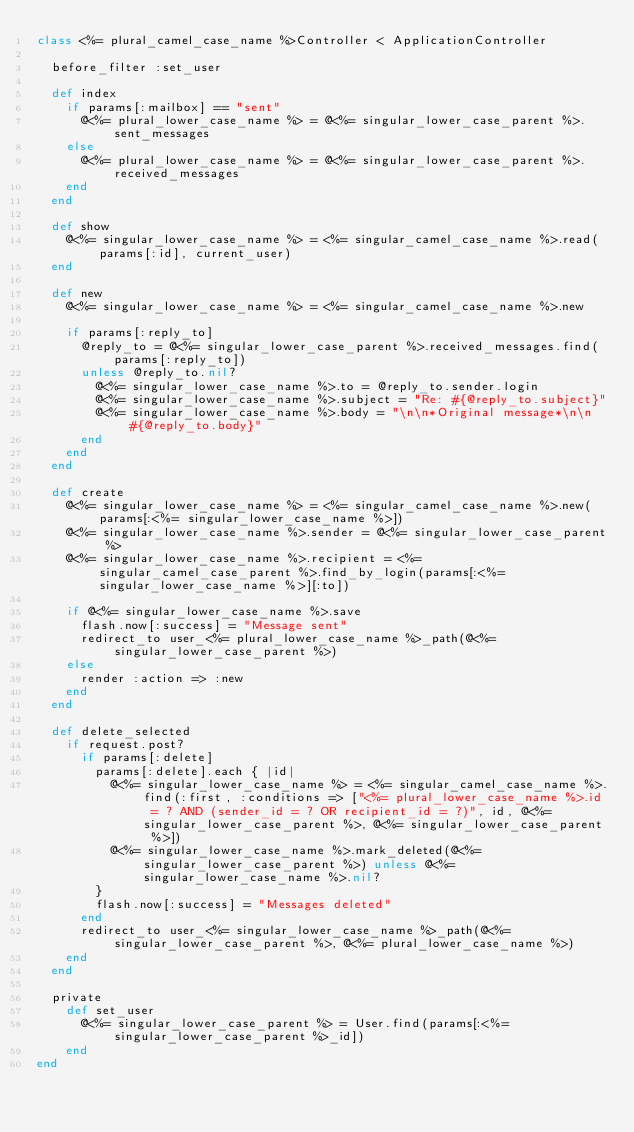<code> <loc_0><loc_0><loc_500><loc_500><_Ruby_>class <%= plural_camel_case_name %>Controller < ApplicationController
  
  before_filter :set_user
  
  def index
    if params[:mailbox] == "sent"
      @<%= plural_lower_case_name %> = @<%= singular_lower_case_parent %>.sent_messages
    else
      @<%= plural_lower_case_name %> = @<%= singular_lower_case_parent %>.received_messages
    end
  end
  
  def show
    @<%= singular_lower_case_name %> = <%= singular_camel_case_name %>.read(params[:id], current_user)
  end
  
  def new
    @<%= singular_lower_case_name %> = <%= singular_camel_case_name %>.new

    if params[:reply_to]
      @reply_to = @<%= singular_lower_case_parent %>.received_messages.find(params[:reply_to])
      unless @reply_to.nil?
        @<%= singular_lower_case_name %>.to = @reply_to.sender.login
        @<%= singular_lower_case_name %>.subject = "Re: #{@reply_to.subject}"
        @<%= singular_lower_case_name %>.body = "\n\n*Original message*\n\n #{@reply_to.body}"
      end
    end
  end
  
  def create
    @<%= singular_lower_case_name %> = <%= singular_camel_case_name %>.new(params[:<%= singular_lower_case_name %>])
    @<%= singular_lower_case_name %>.sender = @<%= singular_lower_case_parent %>
    @<%= singular_lower_case_name %>.recipient = <%= singular_camel_case_parent %>.find_by_login(params[:<%= singular_lower_case_name %>][:to])

    if @<%= singular_lower_case_name %>.save
      flash.now[:success] = "Message sent"
      redirect_to user_<%= plural_lower_case_name %>_path(@<%= singular_lower_case_parent %>)
    else
      render :action => :new
    end
  end
  
  def delete_selected
    if request.post?
      if params[:delete]
        params[:delete].each { |id|
          @<%= singular_lower_case_name %> = <%= singular_camel_case_name %>.find(:first, :conditions => ["<%= plural_lower_case_name %>.id = ? AND (sender_id = ? OR recipient_id = ?)", id, @<%= singular_lower_case_parent %>, @<%= singular_lower_case_parent %>])
          @<%= singular_lower_case_name %>.mark_deleted(@<%= singular_lower_case_parent %>) unless @<%= singular_lower_case_name %>.nil?
        }
        flash.now[:success] = "Messages deleted"
      end
      redirect_to user_<%= singular_lower_case_name %>_path(@<%= singular_lower_case_parent %>, @<%= plural_lower_case_name %>)
    end
  end
  
  private
    def set_user
      @<%= singular_lower_case_parent %> = User.find(params[:<%= singular_lower_case_parent %>_id])
    end
end</code> 